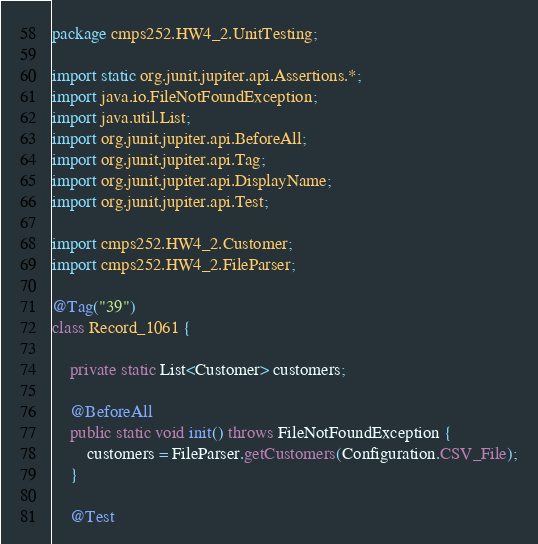<code> <loc_0><loc_0><loc_500><loc_500><_Java_>package cmps252.HW4_2.UnitTesting;

import static org.junit.jupiter.api.Assertions.*;
import java.io.FileNotFoundException;
import java.util.List;
import org.junit.jupiter.api.BeforeAll;
import org.junit.jupiter.api.Tag;
import org.junit.jupiter.api.DisplayName;
import org.junit.jupiter.api.Test;

import cmps252.HW4_2.Customer;
import cmps252.HW4_2.FileParser;

@Tag("39")
class Record_1061 {

	private static List<Customer> customers;

	@BeforeAll
	public static void init() throws FileNotFoundException {
		customers = FileParser.getCustomers(Configuration.CSV_File);
	}

	@Test</code> 